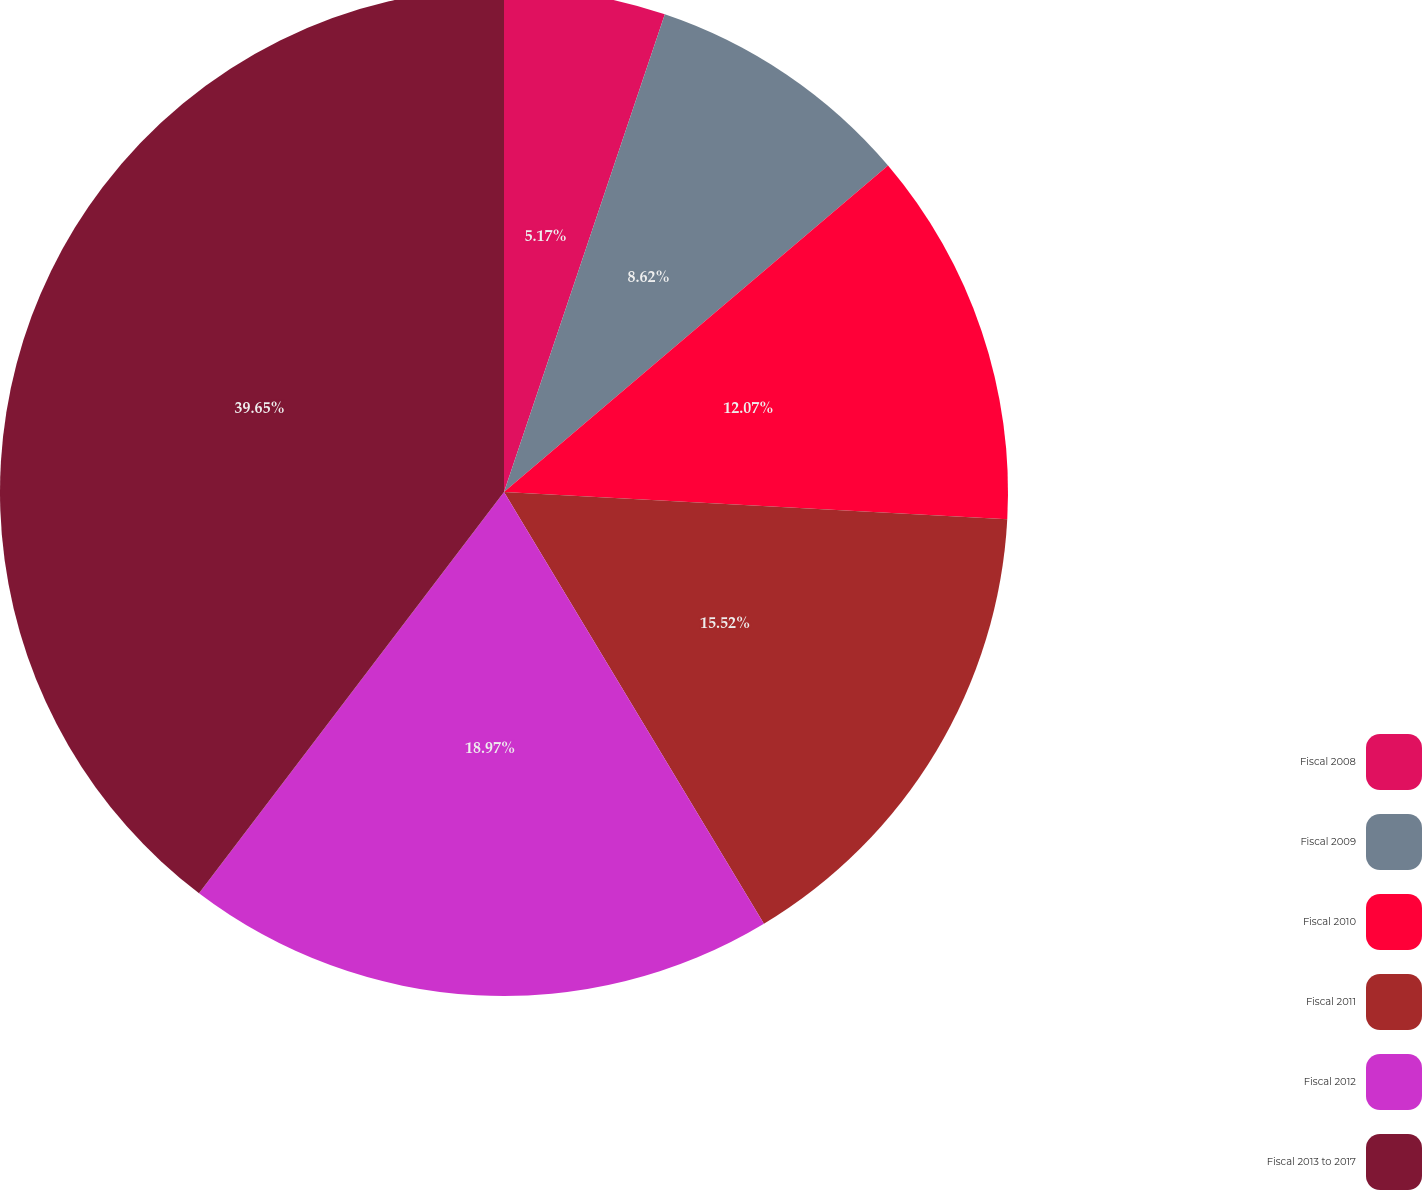Convert chart to OTSL. <chart><loc_0><loc_0><loc_500><loc_500><pie_chart><fcel>Fiscal 2008<fcel>Fiscal 2009<fcel>Fiscal 2010<fcel>Fiscal 2011<fcel>Fiscal 2012<fcel>Fiscal 2013 to 2017<nl><fcel>5.17%<fcel>8.62%<fcel>12.07%<fcel>15.52%<fcel>18.97%<fcel>39.66%<nl></chart> 